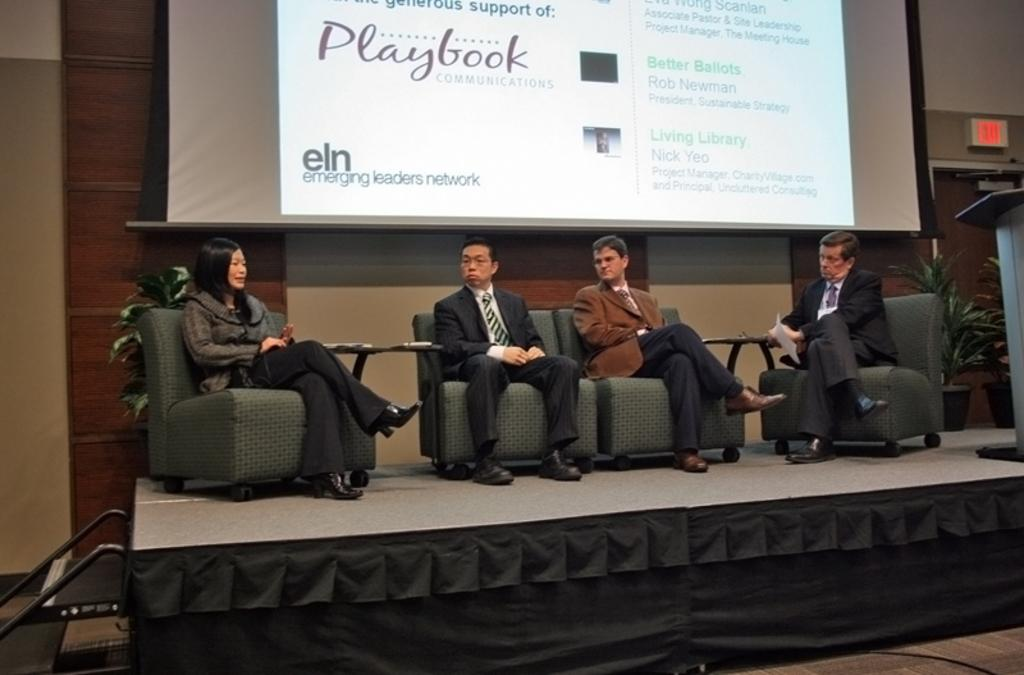How many people are in the image? There is a group of people in the image. What are the people doing in the image? The people are seated on chairs. What is the purpose of the projector screen in the image? The projector screen is likely used for presentations or visual aids. What is the podium used for in the image? The podium is likely used for speakers or presenters to stand behind while addressing the group. How many chickens are present in the image? There are no chickens present in the image. What type of activity is the group of people participating in, as seen in the image? The image does not provide enough information to determine the specific activity the group of people is participating in. 